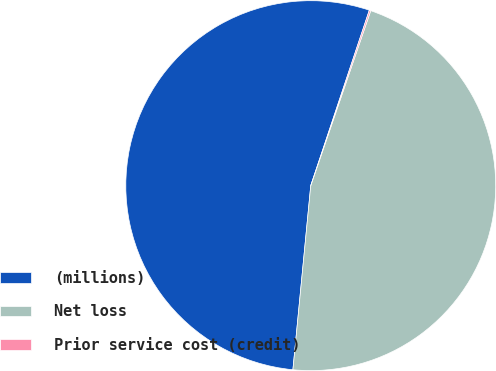<chart> <loc_0><loc_0><loc_500><loc_500><pie_chart><fcel>(millions)<fcel>Net loss<fcel>Prior service cost (credit)<nl><fcel>53.59%<fcel>46.28%<fcel>0.13%<nl></chart> 